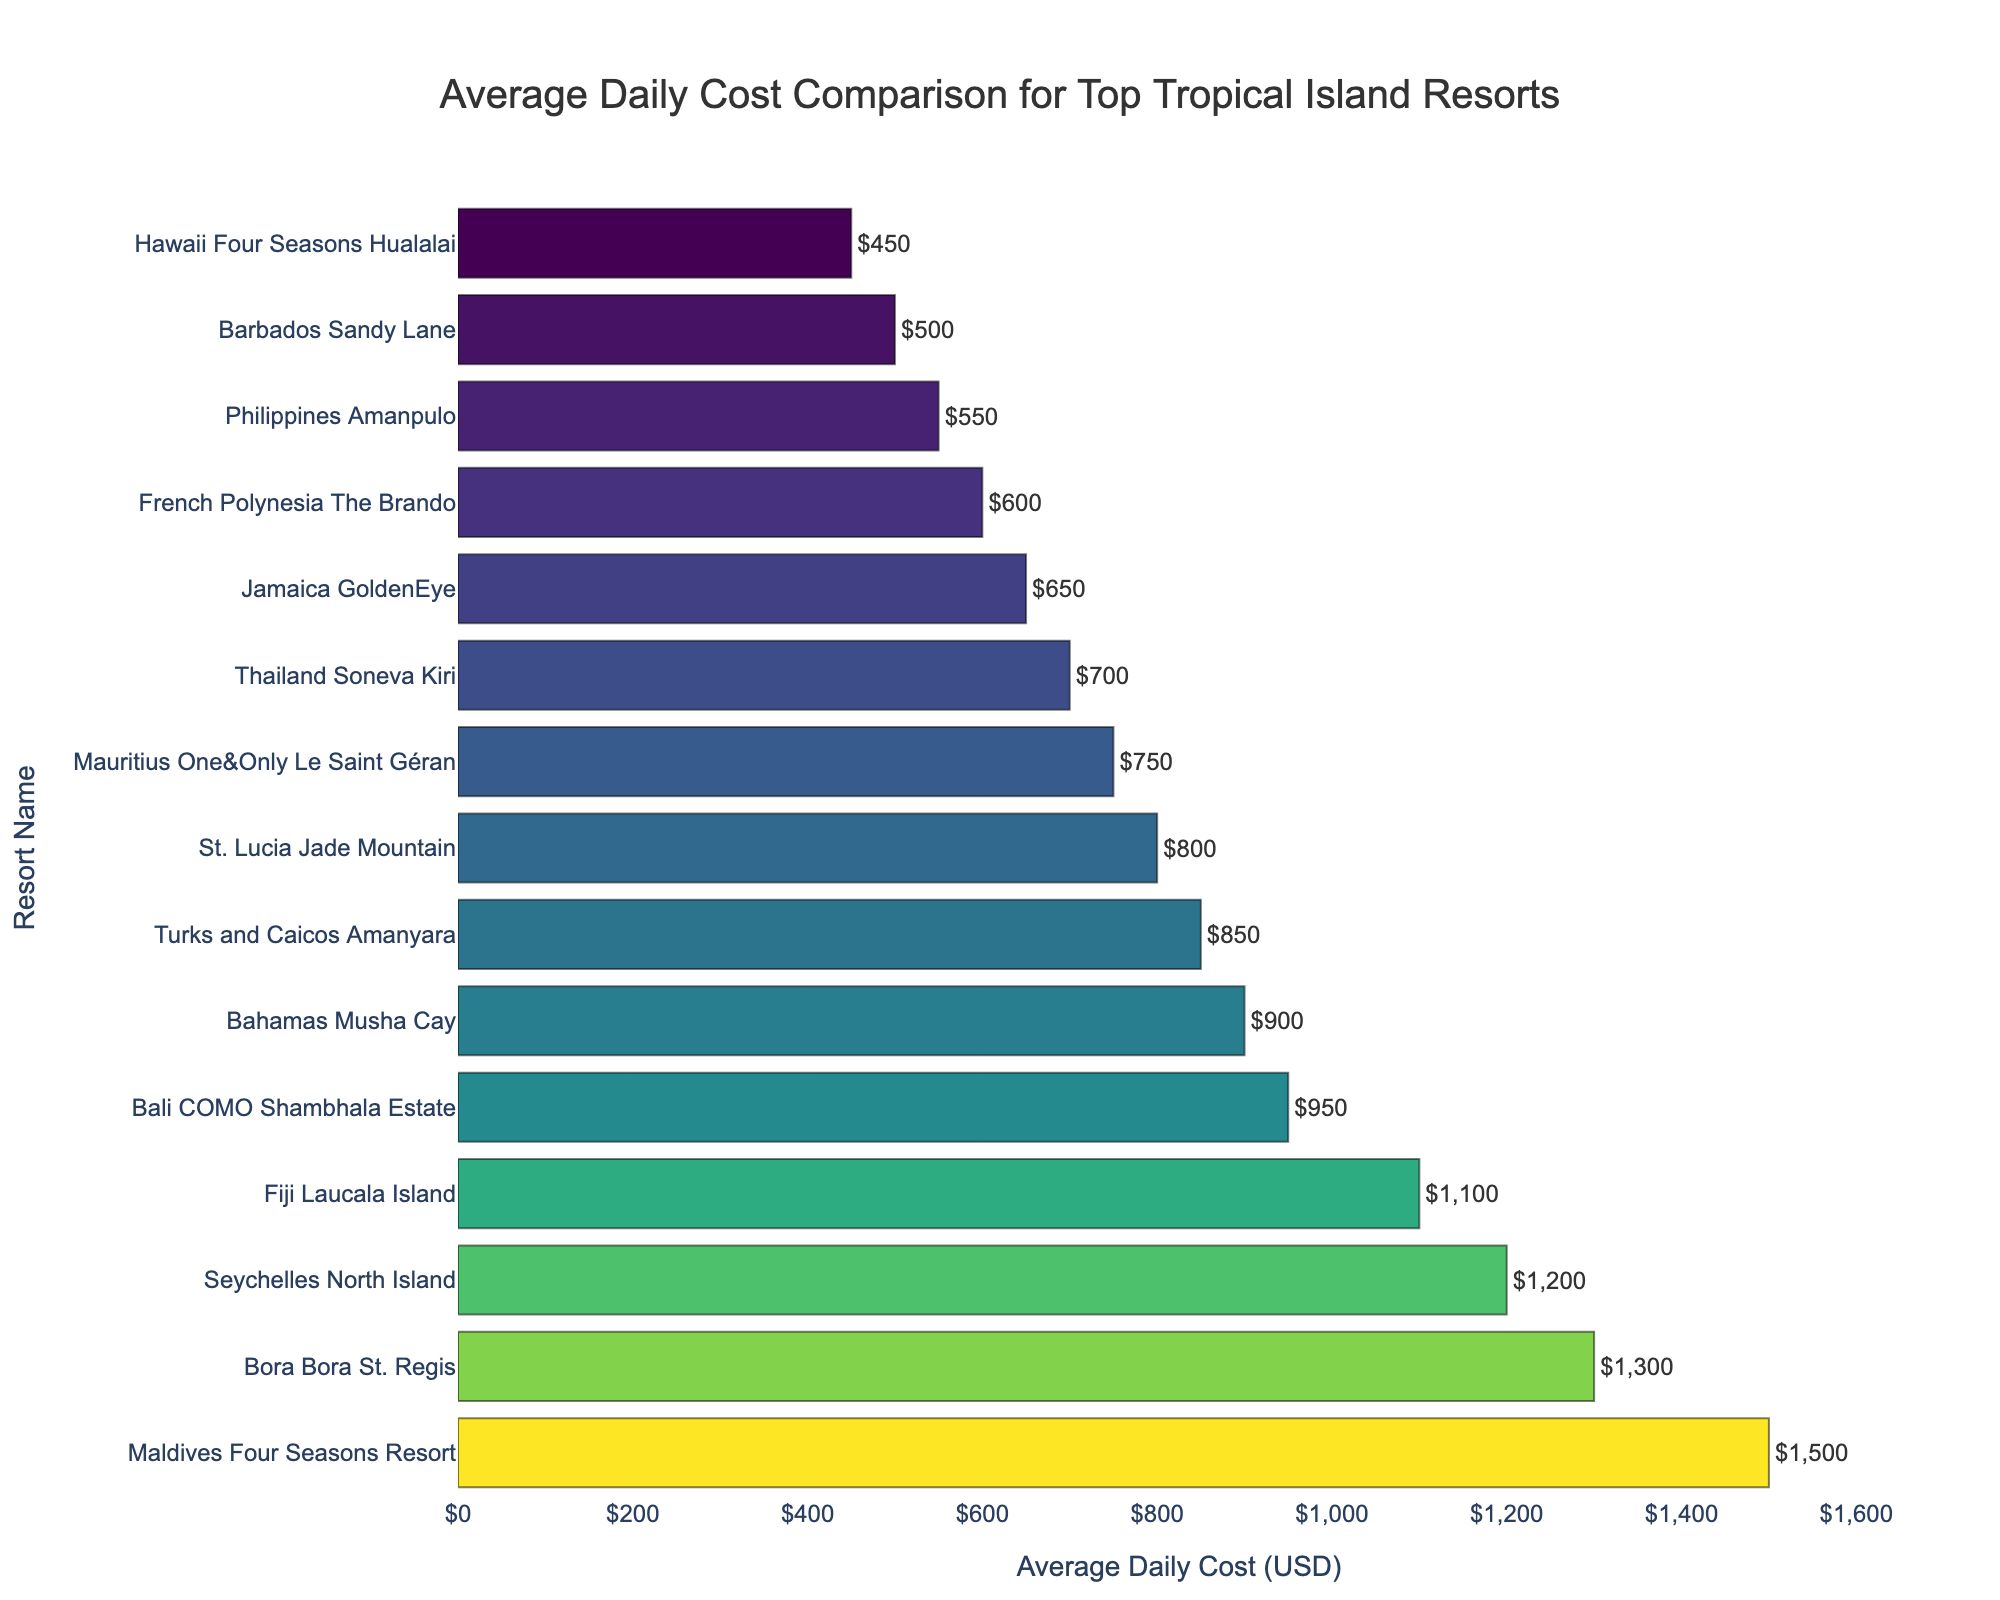Which resort has the highest average daily cost? Locate the bar with the highest value on the horizontal axis, which corresponds to the resort listed on the left. The highest bar represents the Maldives Four Seasons Resort.
Answer: Maldives Four Seasons Resort Which resort has the lowest average daily cost? Identify the bar with the lowest value on the horizontal axis, corresponding to the last resort listed on the left. This bar represents the Hawaii Four Seasons Hualalai.
Answer: Hawaii Four Seasons Hualalai What is the average daily cost difference between the Maldives Four Seasons Resort and the Bora Bora St. Regis? Find the average daily cost of the Maldives Four Seasons Resort ($1,500) and the Bora Bora St. Regis ($1,300). Subtract the cost of the Bora Bora St. Regis from the cost of the Maldives Four Seasons Resort: $1,500 - $1,300 = $200.
Answer: $200 What is the total average daily cost for the top three most expensive resorts? Identify the top three most expensive resorts and sum their average daily costs. The resorts are Maldives Four Seasons Resort ($1,500), Bora Bora St. Regis ($1,300), and Seychelles North Island ($1,200). Calculate the total cost: $1,500 + $1,300 + $1,200 = $4,000.
Answer: $4,000 Among the Bahamas Musha Cay, Turks and Caicos Amanyara, and St. Lucia Jade Mountain, which resort is the least expensive? Compare the average daily costs of the three resorts: Bahamas Musha Cay ($900), Turks and Caicos Amanyara ($850), and St. Lucia Jade Mountain ($800). The lowest value is for St. Lucia Jade Mountain.
Answer: St. Lucia Jade Mountain How much more does it cost on average to stay at the Bali COMO Shambhala Estate compared to the French Polynesia The Brando? Find the average daily costs for Bali COMO Shambhala Estate ($950) and French Polynesia The Brando ($600). Subtract the cost of French Polynesia The Brando from the cost of Bali COMO Shambhala Estate: $950 - $600 = $350.
Answer: $350 What is the average daily cost difference between the most and least expensive resorts? Find the average daily cost for the most expensive resort (Maldives Four Seasons Resort, $1,500) and the least expensive resort (Hawaii Four Seasons Hualalai, $450). Calculate the difference: $1,500 - $450 = $1,050.
Answer: $1,050 What's the average cost of staying at the top 10 most expensive resorts? The top 10 most expensive resorts are: Maldives Four Seasons Resort ($1,500), Bora Bora St. Regis ($1,300), Seychelles North Island ($1,200), Fiji Laucala Island ($1,100), Bali COMO Shambhala Estate ($950), Bahamas Musha Cay ($900), Turks and Caicos Amanyara ($850), St. Lucia Jade Mountain ($800), Mauritius One&Only Le Saint Géran ($750), and Thailand Soneva Kiri ($700). Sum their costs and divide by 10: ($1,500 + $1,300 + $1,200 + $1,100 + $950 + $900 + $850 + $800 + $750 + $700)/10 = $9,050/10 = $905.
Answer: $905 Which resorts have an average daily cost between $600 and $1000? Identify the resorts with average daily costs within the range of $600 to $1000: Bali COMO Shambhala Estate ($950), Bahamas Musha Cay ($900), Turks and Caicos Amanyara ($850), St. Lucia Jade Mountain ($800), Mauritius One&Only Le Saint Géran ($750), and Thailand Soneva Kiri ($700).
Answer: Bali COMO Shambhala Estate, Bahamas Musha Cay, Turks and Caicos Amanyara, St. Lucia Jade Mountain, Mauritius One&Only Le Saint Géran, Thailand Soneva Kiri 